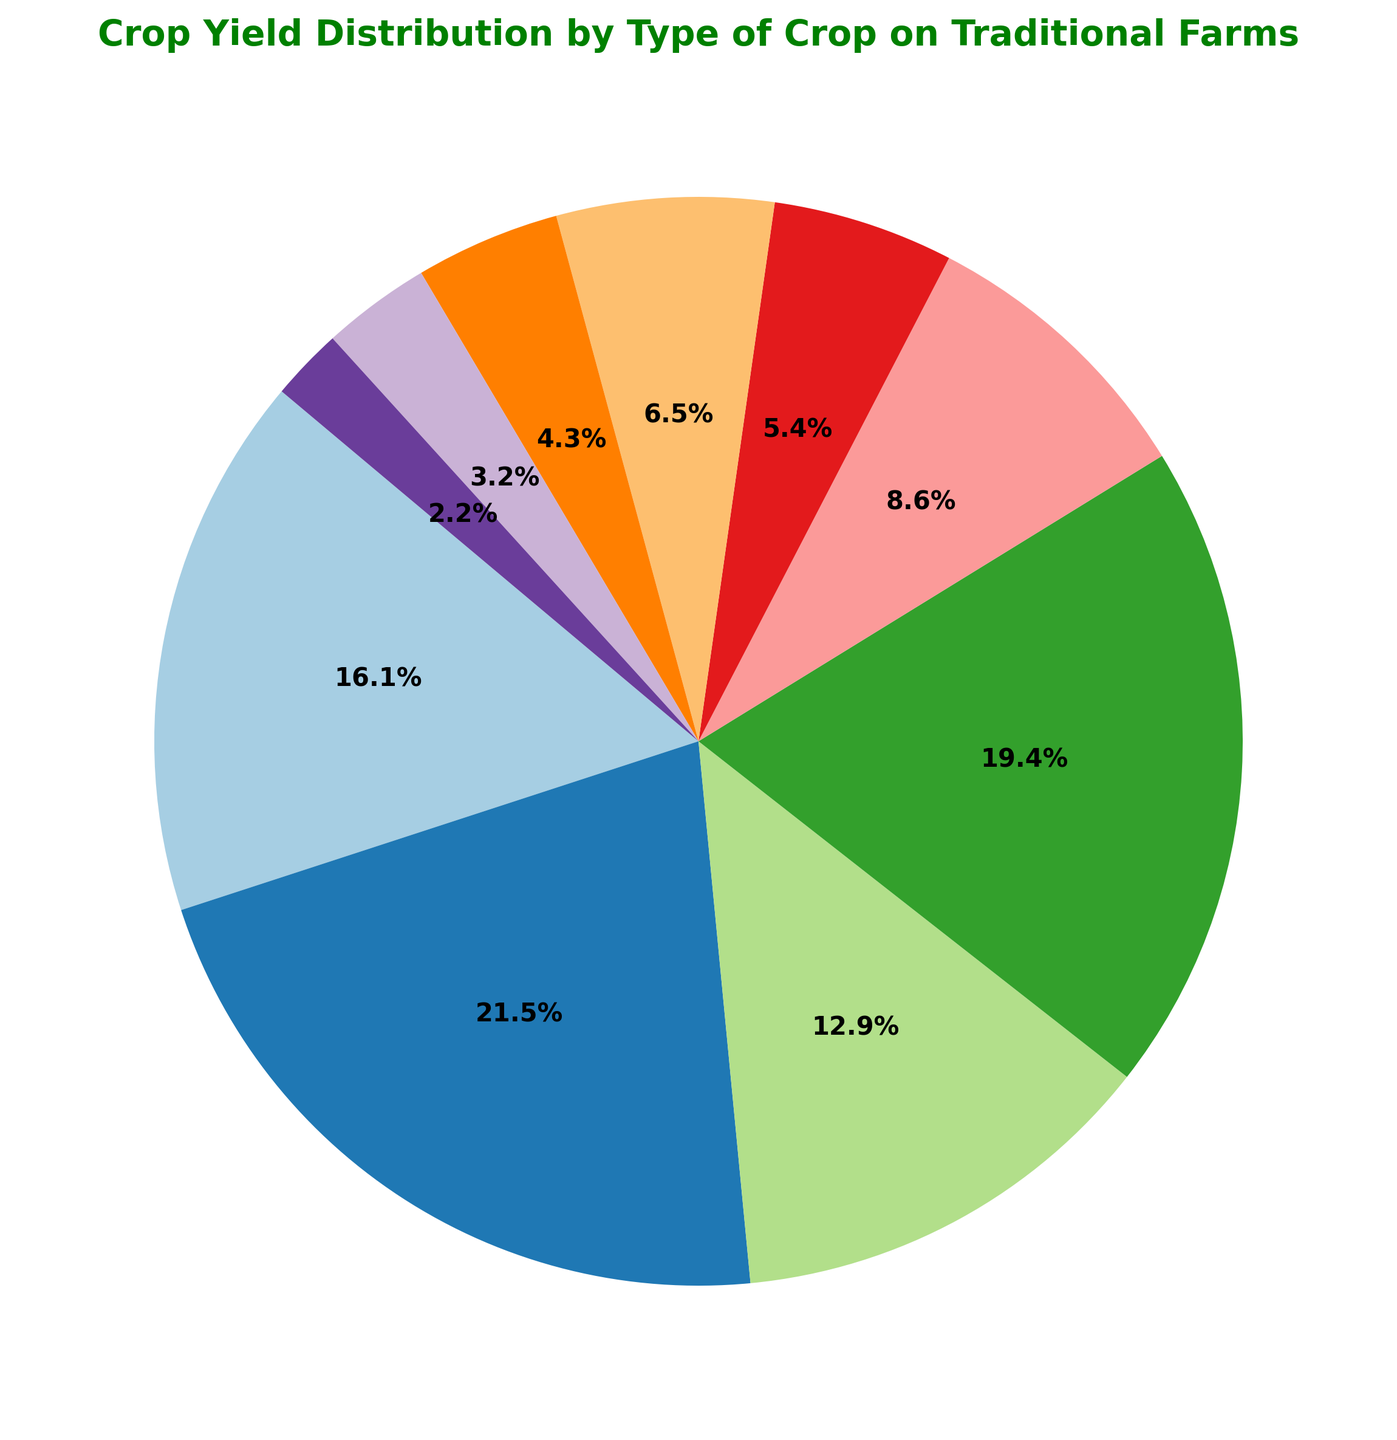What's the most abundant crop type in terms of yield? First, identify the crop with the largest sector in the pie chart. This will be the crop that makes up the highest percentage of the pie.
Answer: Corn Which crop type has the smallest yield percentage? Look for the smallest sector in the pie chart, which represents the smallest percentage of the total yield.
Answer: Tobacco How much more yield does Barley have compared to Peanuts? Find the yields of Barley and Peanuts. Barley has 80 tons and Peanuts have 40 tons. Calculate the difference: 80 - 40 = 40 tons.
Answer: 40 tons What percentage of the total yield is made up by Wheat and Rice combined? Find the percentages corresponding to Wheat and Rice in the pie chart. Wheat is 21.1% and Rice is 25.4%. Add these percentages: 21.1% + 25.4% = 46.5%.
Answer: 46.5% Which crops yield more than 100 tons? Identify the sectors larger than the sector representing 100 tons. The crops are Wheat, Corn, Rice, and Soybeans.
Answer: Wheat, Corn, Rice, Soybeans How does the area of the Soybeans sector compare to the area of the Oats sector? Compare their respective percentages in the pie chart. Soybeans is 16.8% and Oats is 7.0%, so Soybeans represents a larger area.
Answer: Soybeans sector is larger What is the combined percentage of the yield of crops other than Corn and Rice? Calculate the total percentage and subtract the percentages of Corn and Rice. Total is 100%, Corn is 28.2%, and Rice is 25.4%. So, 100% - 28.2% - 25.4% = 46.4%.
Answer: 46.4% Which has a higher yield percentage, Barley or Oats? Compare the individual percentages from the pie chart. Barley is 11.3% and Oats is 7.0%, making Barley higher.
Answer: Barley By what factor is the yield of Corn greater than the yield of Tobacco? Determine the yields for Corn and Tobacco. Corn is 200 tons and Tobacco is 20 tons. Divide the yield of Corn by the yield of Tobacco: 200 / 20 = 10.
Answer: 10 What is the approximate percentage yield of crops yielding less than 100 tons? Sum the percentages of sectors representing crops with yields under 100 tons: Barley (11.3%), Oats (7.0%), Sorghum (8.4%), Peanuts (5.6%), Cotton (4.2%), and Tobacco (2.8%): 11.3% + 7.0% + 8.4% + 5.6% + 4.2% + 2.8% = 39.3%.
Answer: 39.3% 